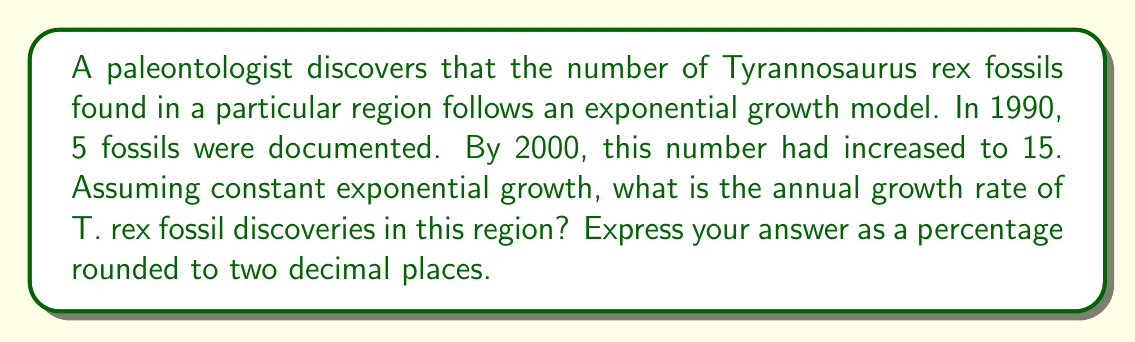Teach me how to tackle this problem. Let's approach this step-by-step using the exponential growth formula:

1) The exponential growth formula is:
   $A = P(1 + r)^t$
   Where:
   $A$ = Final amount
   $P$ = Initial amount
   $r$ = Annual growth rate (in decimal form)
   $t$ = Time in years

2) We know:
   $P = 5$ (fossils in 1990)
   $A = 15$ (fossils in 2000)
   $t = 10$ years

3) Let's plug these into our formula:
   $15 = 5(1 + r)^{10}$

4) Divide both sides by 5:
   $3 = (1 + r)^{10}$

5) Take the 10th root of both sides:
   $\sqrt[10]{3} = 1 + r$

6) Subtract 1 from both sides:
   $\sqrt[10]{3} - 1 = r$

7) Calculate:
   $r = \sqrt[10]{3} - 1 \approx 0.1158$

8) Convert to a percentage:
   $0.1158 \times 100 = 11.58\%$

9) Round to two decimal places:
   $11.58\%$
Answer: 11.58% 